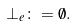Convert formula to latex. <formula><loc_0><loc_0><loc_500><loc_500>\bot _ { e } \colon = \emptyset .</formula> 